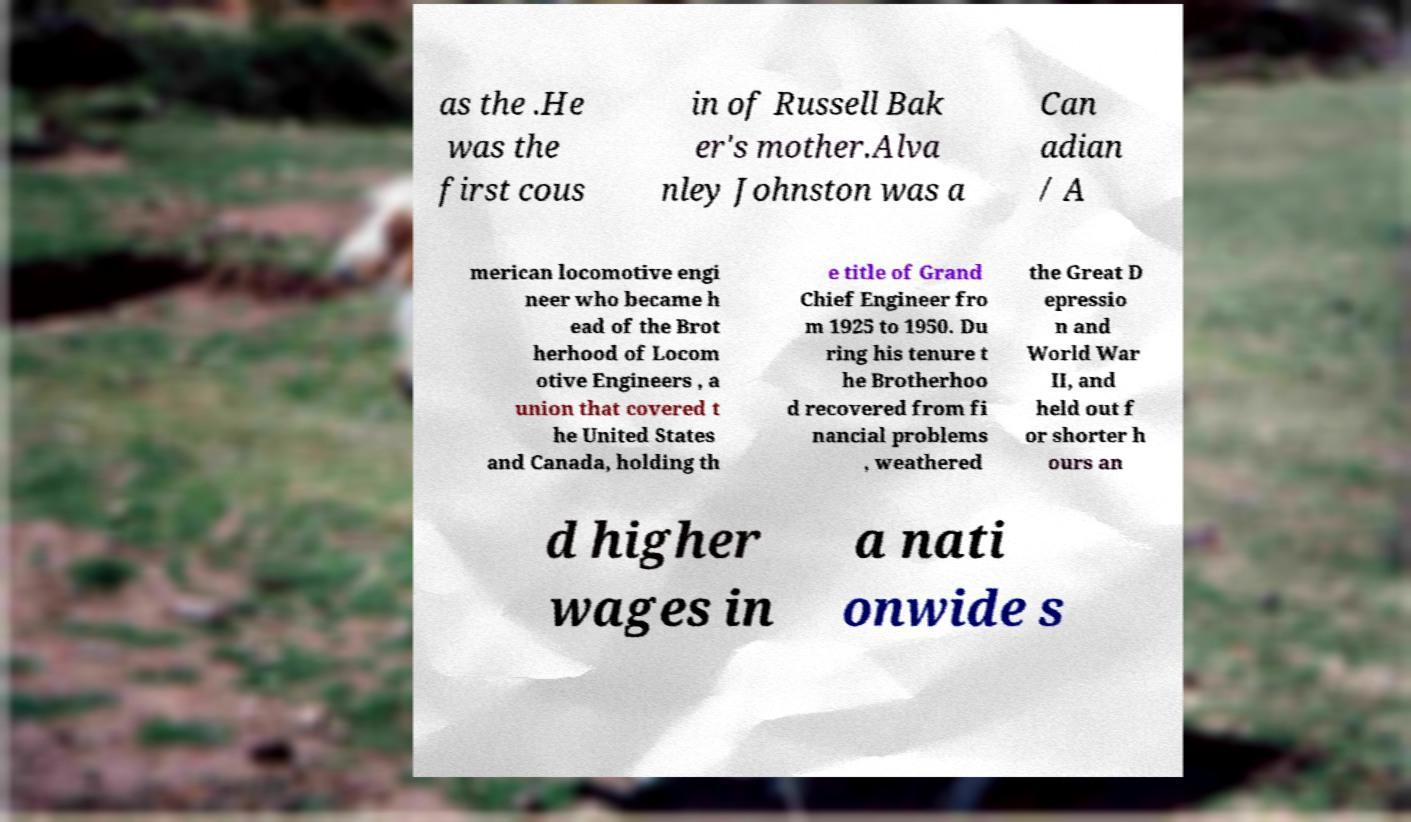Could you extract and type out the text from this image? as the .He was the first cous in of Russell Bak er's mother.Alva nley Johnston was a Can adian / A merican locomotive engi neer who became h ead of the Brot herhood of Locom otive Engineers , a union that covered t he United States and Canada, holding th e title of Grand Chief Engineer fro m 1925 to 1950. Du ring his tenure t he Brotherhoo d recovered from fi nancial problems , weathered the Great D epressio n and World War II, and held out f or shorter h ours an d higher wages in a nati onwide s 